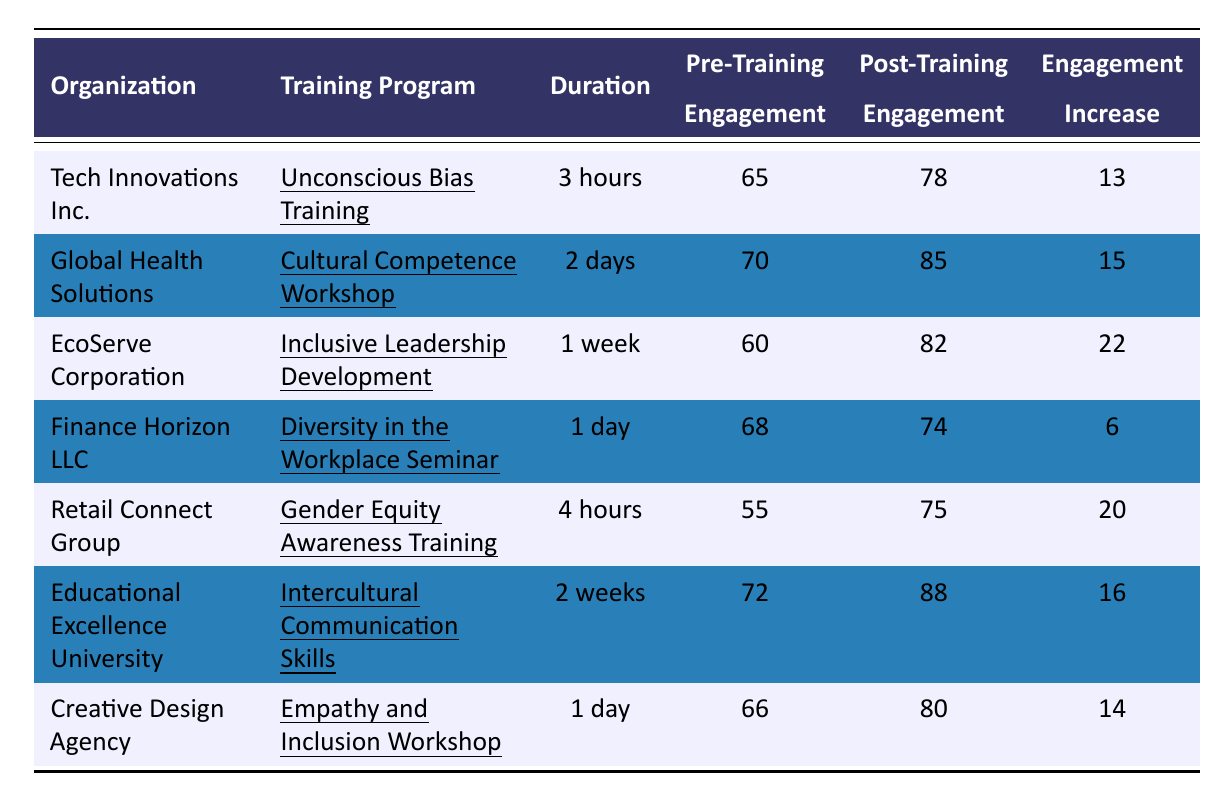What is the engagement increase for EcoServe Corporation? The table shows that EcoServe Corporation has an engagement increase of 22.
Answer: 22 Which organization had the highest post-training engagement? Looking at the post-training engagement values, EcoServe Corporation had the highest score of 82.
Answer: EcoServe Corporation What was the pre-training engagement level for Retail Connect Group? The table indicates that the pre-training engagement level for Retail Connect Group was 55.
Answer: 55 What is the average engagement increase across all organizations? The engagement increases are 13, 15, 22, 6, 20, 16, and 14. Adding them gives 106, and dividing by 7 results in an average engagement increase of approximately 15.14.
Answer: Approximately 15.14 Did Finance Horizon LLC experience an engagement increase greater than 10? The engagement increase for Finance Horizon LLC is 6, which is less than 10.
Answer: No Which training program had the shortest duration? Looking at the durations provided, the Unconscious Bias Training at Tech Innovations Inc. lasted for 3 hours, which is the shortest.
Answer: Unconscious Bias Training How many organizations had a post-training engagement level above 80? The organizations with post-training engagement levels above 80 are Global Health Solutions (85), EcoServe Corporation (82), and Educational Excellence University (88). That is a total of 3 organizations.
Answer: 3 What is the difference in pre-training engagement between the organization with the highest and lowest pre-training engagement? The highest pre-training engagement is 72 for Educational Excellence University, and the lowest is 55 for Retail Connect Group. The difference is 72 - 55 = 17.
Answer: 17 Which training program resulted in the largest increase in engagement? The largest engagement increase recorded is 22 for EcoServe Corporation's Inclusive Leadership Development program.
Answer: Inclusive Leadership Development Did any training program last longer than 1 week? The table shows that no training program exceeded 1 week in duration, as the maximum is 2 weeks for Intercultural Communication Skills, which is not longer than a week.
Answer: No 